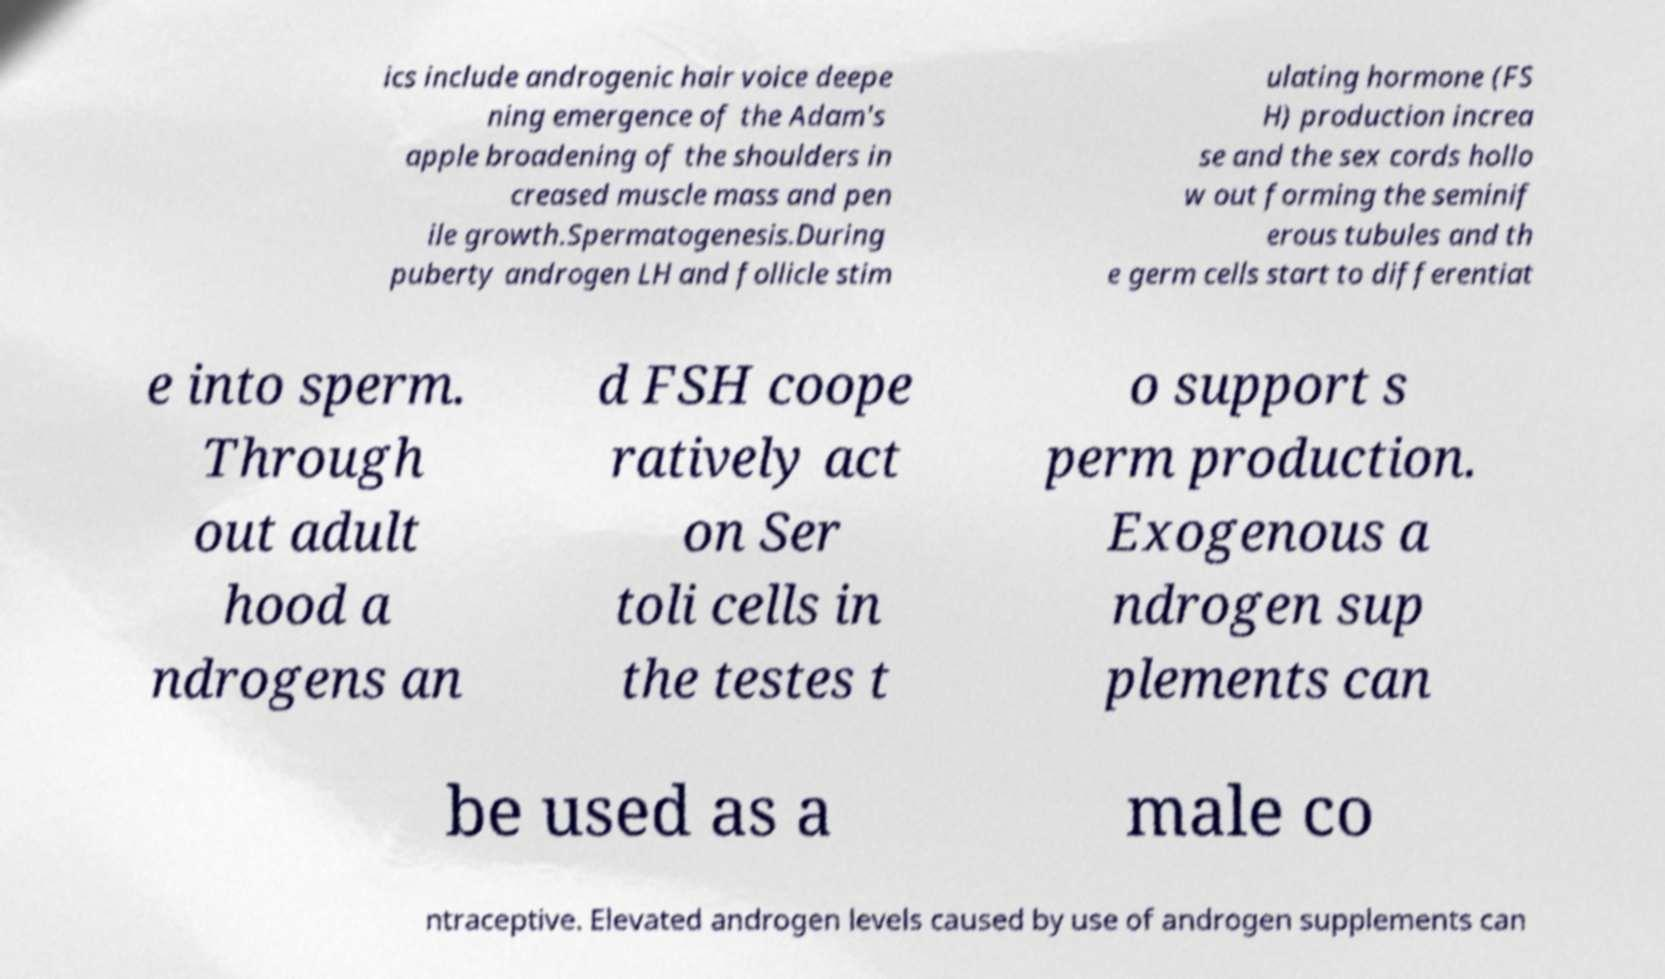Can you accurately transcribe the text from the provided image for me? ics include androgenic hair voice deepe ning emergence of the Adam's apple broadening of the shoulders in creased muscle mass and pen ile growth.Spermatogenesis.During puberty androgen LH and follicle stim ulating hormone (FS H) production increa se and the sex cords hollo w out forming the seminif erous tubules and th e germ cells start to differentiat e into sperm. Through out adult hood a ndrogens an d FSH coope ratively act on Ser toli cells in the testes t o support s perm production. Exogenous a ndrogen sup plements can be used as a male co ntraceptive. Elevated androgen levels caused by use of androgen supplements can 